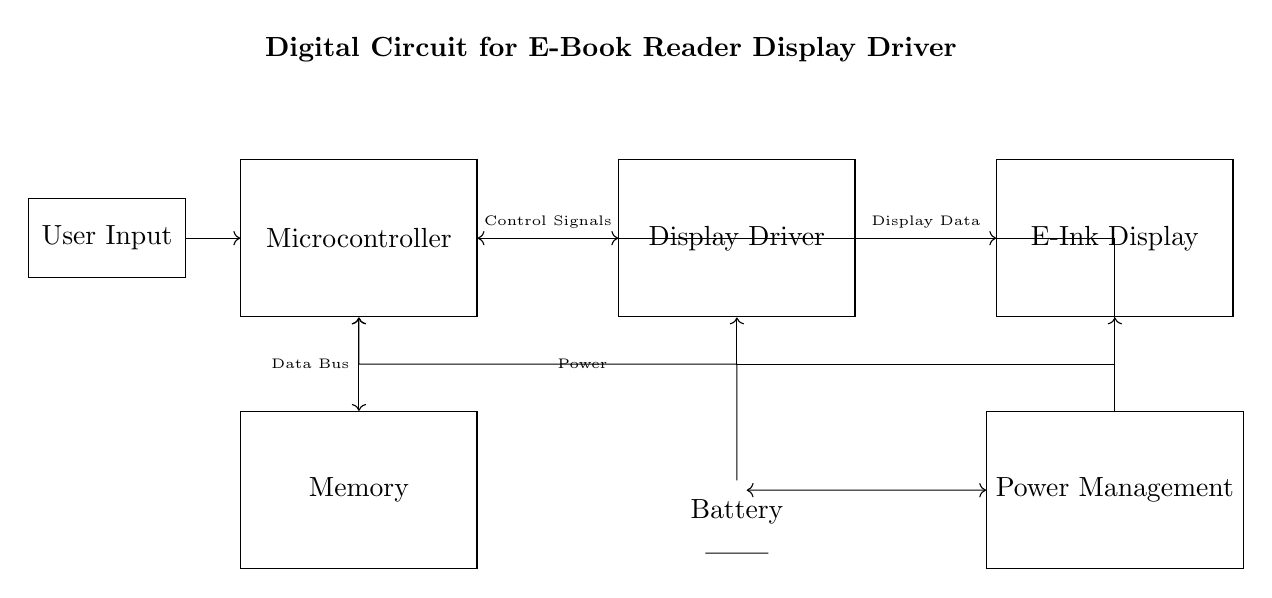What is the function of the microcontroller? The microcontroller's role is to manage control signals to the display driver and communicate with memory for data.
Answer: Manage control signals What does the display driver connect to? The display driver has connections to the microcontroller for control signals and to the e-ink display for display data.
Answer: Microcontroller and e-ink display How many main components are in this circuit? There are five main components: microcontroller, display driver, e-ink display, memory, and power management.
Answer: Five What flows from the battery to the microcontroller? Power flows from the battery to the microcontroller, ensuring it has the necessary energy to operate.
Answer: Power Why does the display require a display driver? The display driver converts the data received from the microcontroller into a format suitable for the e-ink display to render images.
Answer: To convert data for rendering What is the role of the power management unit? The power management unit regulates and distributes power to the microcontroller, display driver, and battery, ensuring efficient power usage.
Answer: Regulate and distribute power How do user inputs affect the microcontroller? User inputs are sent to the microcontroller, allowing it to process the inputs for control signals and data operations.
Answer: Process control signals 